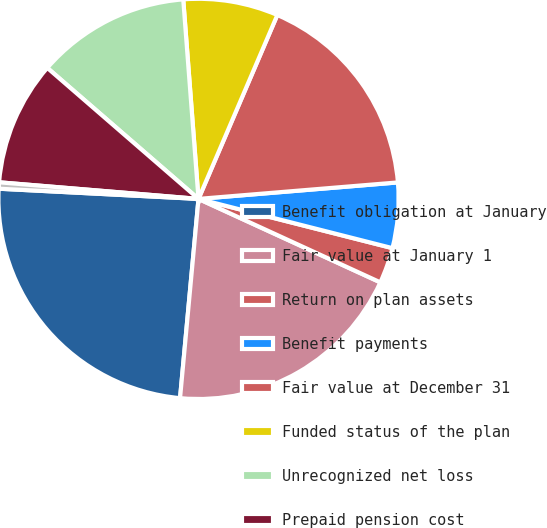Convert chart. <chart><loc_0><loc_0><loc_500><loc_500><pie_chart><fcel>Benefit obligation at January<fcel>Fair value at January 1<fcel>Return on plan assets<fcel>Benefit payments<fcel>Fair value at December 31<fcel>Funded status of the plan<fcel>Unrecognized net loss<fcel>Prepaid pension cost<fcel>Accumulated other<nl><fcel>24.34%<fcel>19.62%<fcel>2.89%<fcel>5.27%<fcel>17.24%<fcel>7.66%<fcel>12.42%<fcel>10.04%<fcel>0.51%<nl></chart> 